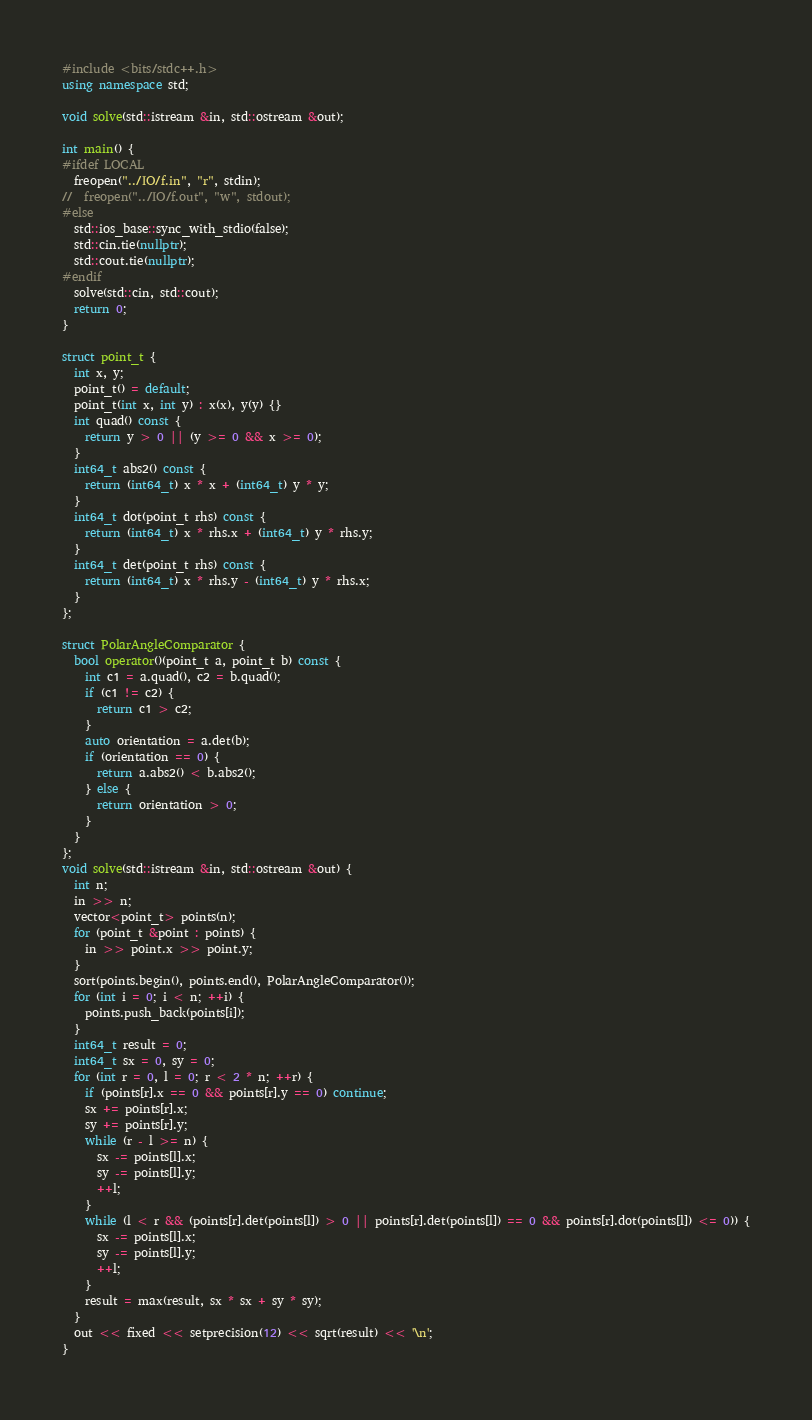<code> <loc_0><loc_0><loc_500><loc_500><_C++_>#include <bits/stdc++.h>
using namespace std;

void solve(std::istream &in, std::ostream &out);

int main() {
#ifdef LOCAL
  freopen("../IO/f.in", "r", stdin);
//  freopen("../IO/f.out", "w", stdout);
#else
  std::ios_base::sync_with_stdio(false);
  std::cin.tie(nullptr);
  std::cout.tie(nullptr);
#endif
  solve(std::cin, std::cout);
  return 0;
}

struct point_t {
  int x, y;
  point_t() = default;
  point_t(int x, int y) : x(x), y(y) {}
  int quad() const {
    return y > 0 || (y >= 0 && x >= 0);
  }
  int64_t abs2() const {
    return (int64_t) x * x + (int64_t) y * y;
  }
  int64_t dot(point_t rhs) const {
    return (int64_t) x * rhs.x + (int64_t) y * rhs.y;
  }
  int64_t det(point_t rhs) const {
    return (int64_t) x * rhs.y - (int64_t) y * rhs.x;
  }
};

struct PolarAngleComparator {
  bool operator()(point_t a, point_t b) const {
    int c1 = a.quad(), c2 = b.quad();
    if (c1 != c2) {
      return c1 > c2;
    }
    auto orientation = a.det(b);
    if (orientation == 0) {
      return a.abs2() < b.abs2();
    } else {
      return orientation > 0;
    }
  }
};
void solve(std::istream &in, std::ostream &out) {
  int n;
  in >> n;
  vector<point_t> points(n);
  for (point_t &point : points) {
    in >> point.x >> point.y;
  }
  sort(points.begin(), points.end(), PolarAngleComparator());
  for (int i = 0; i < n; ++i) {
    points.push_back(points[i]);
  }
  int64_t result = 0;
  int64_t sx = 0, sy = 0;
  for (int r = 0, l = 0; r < 2 * n; ++r) {
    if (points[r].x == 0 && points[r].y == 0) continue;
    sx += points[r].x;
    sy += points[r].y;
    while (r - l >= n) {
      sx -= points[l].x;
      sy -= points[l].y;
      ++l;
    }
    while (l < r && (points[r].det(points[l]) > 0 || points[r].det(points[l]) == 0 && points[r].dot(points[l]) <= 0)) {
      sx -= points[l].x;
      sy -= points[l].y;
      ++l;
    }
    result = max(result, sx * sx + sy * sy);
  }
  out << fixed << setprecision(12) << sqrt(result) << '\n';
}
</code> 